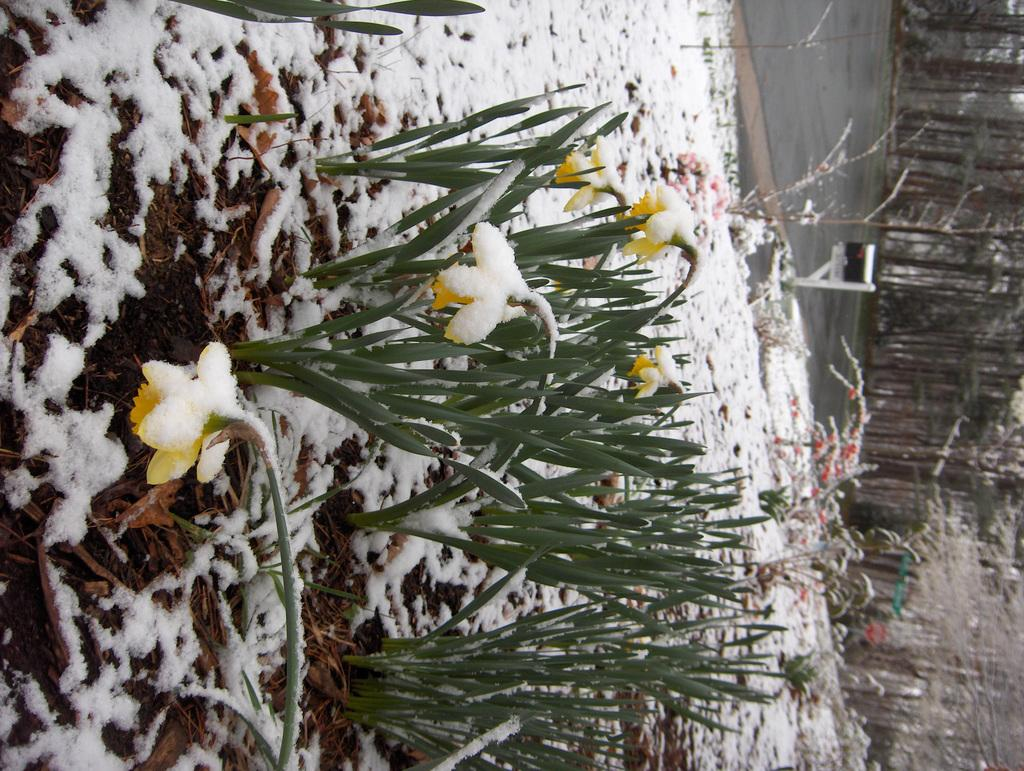What type of plants are in the image? There are plants with flowers in the image. What can be seen in the background of the image? There is a road, snow, trees, and some unspecified objects visible in the background of the image. What type of school can be seen in the image? There is no school present in the image. What kind of lamp is illuminating the plants in the image? There is no lamp present in the image; the plants are not illuminated by a lamp. 